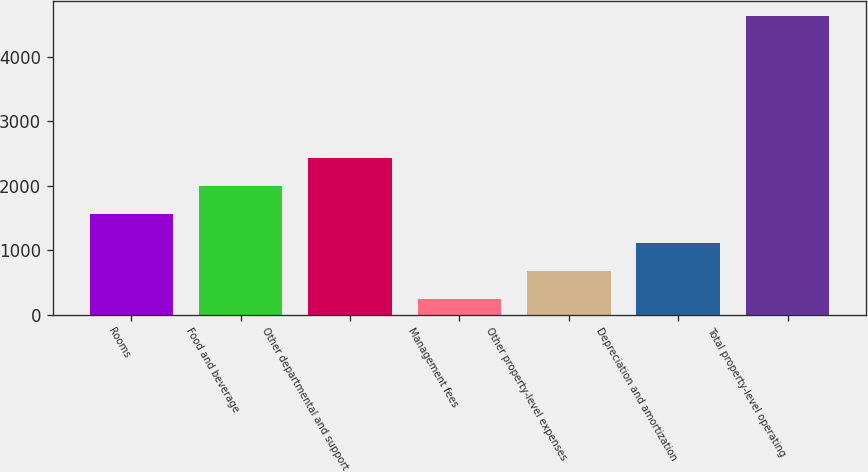Convert chart to OTSL. <chart><loc_0><loc_0><loc_500><loc_500><bar_chart><fcel>Rooms<fcel>Food and beverage<fcel>Other departmental and support<fcel>Management fees<fcel>Other property-level expenses<fcel>Depreciation and amortization<fcel>Total property-level operating<nl><fcel>1555.4<fcel>1994.2<fcel>2433<fcel>239<fcel>677.8<fcel>1116.6<fcel>4627<nl></chart> 